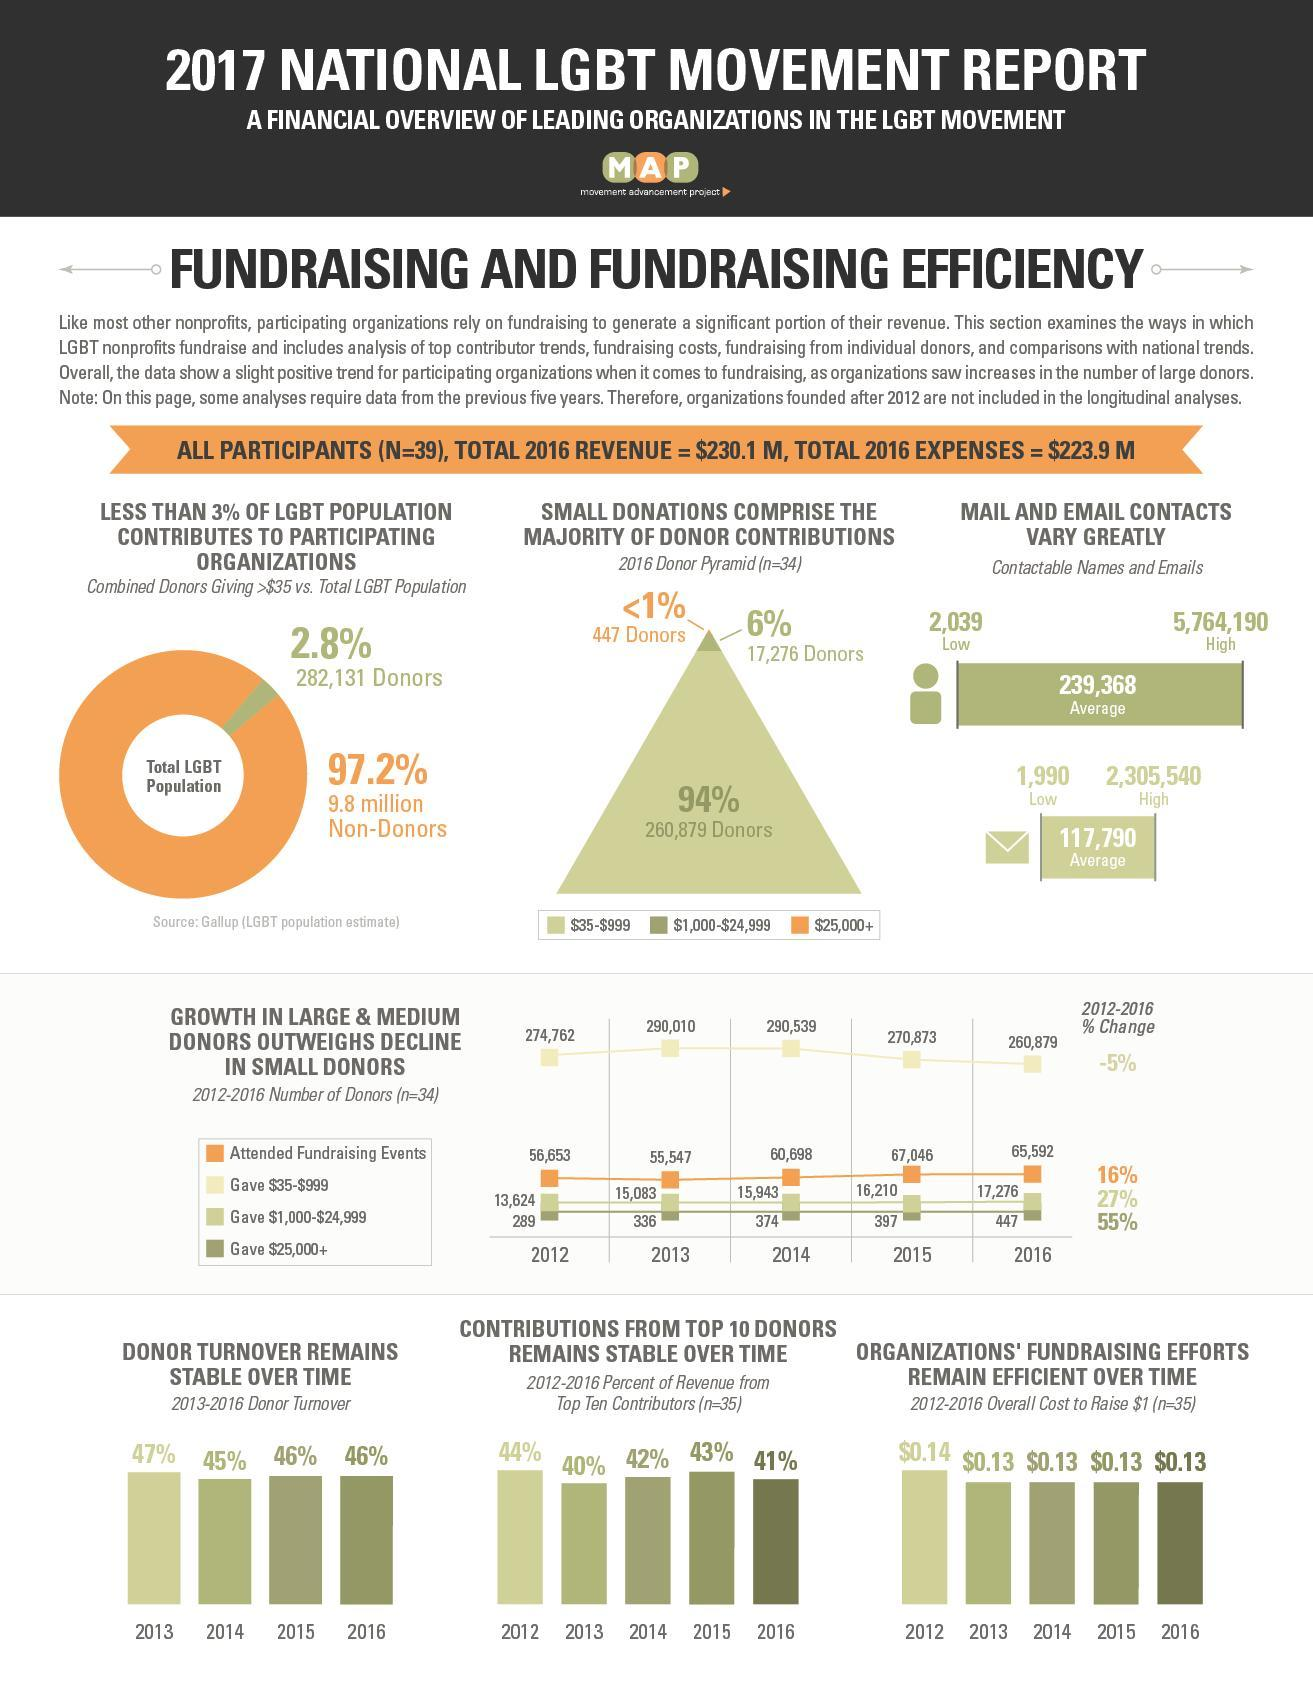for how many years has the overall cost for fundraising been the same
Answer the question with a short phrase. 4 what was the increase in attendees in fund raising events from 2013 to 2014 5151 Donor turnover in which year has been the same as 2016 2015 What % of the total LGBT population contribute to participating organisations as per pie chart 2.8% what was the increase in contributors from 2012 to 2016 who gave between $1,000-$24,999 3652 What % of the total LGBT population do not contribute to participating organisations as per pie chart 97.2% what was the increase in contributors from 2012 to 2016 who gave  $25,000+ 158 